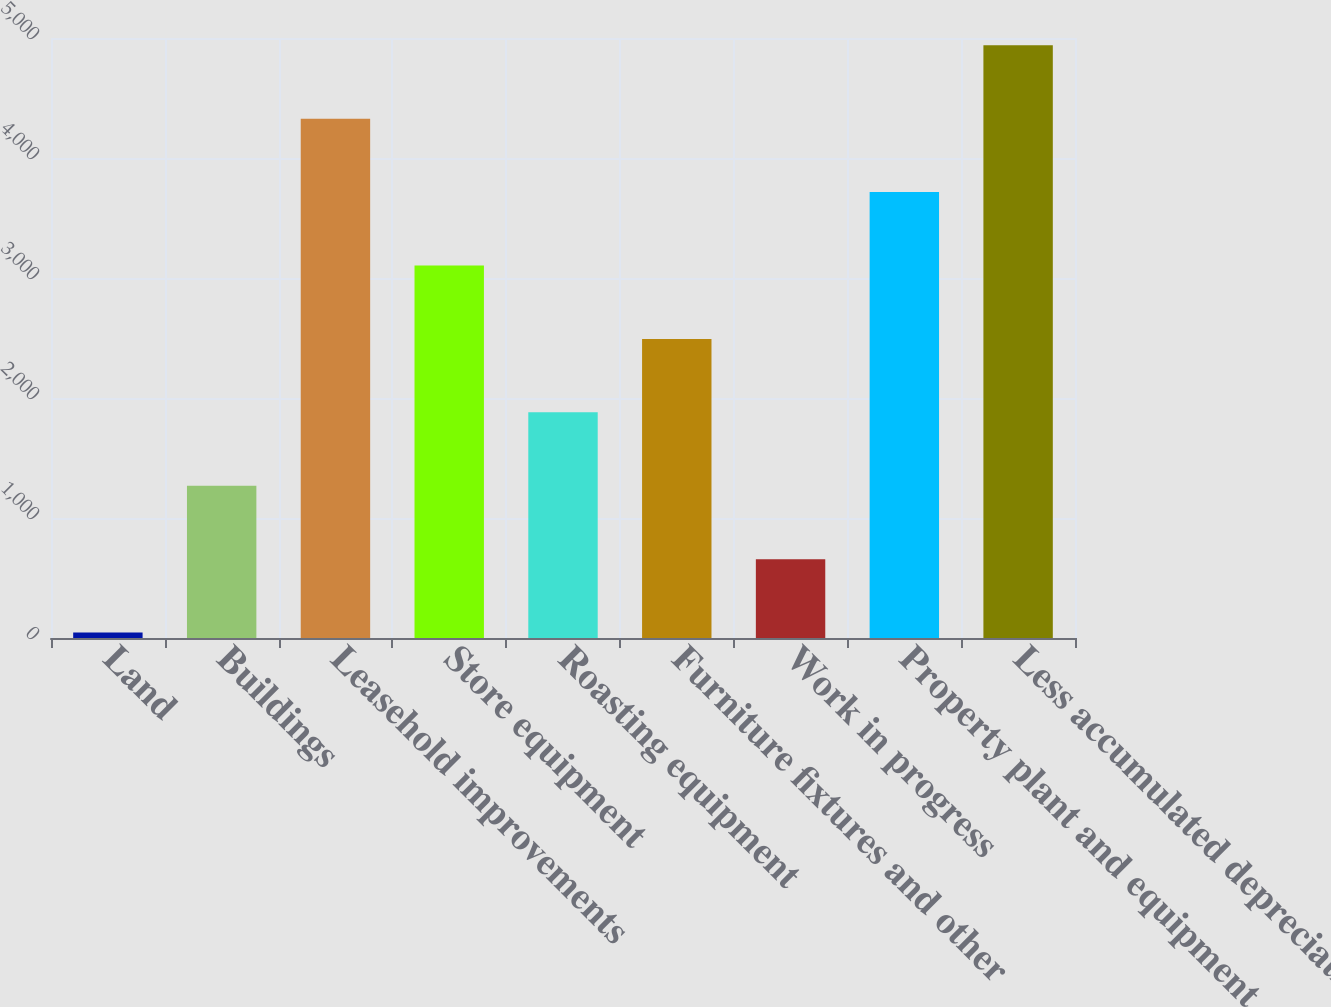Convert chart to OTSL. <chart><loc_0><loc_0><loc_500><loc_500><bar_chart><fcel>Land<fcel>Buildings<fcel>Leasehold improvements<fcel>Store equipment<fcel>Roasting equipment<fcel>Furniture fixtures and other<fcel>Work in progress<fcel>Property plant and equipment<fcel>Less accumulated depreciation<nl><fcel>44.8<fcel>1268.46<fcel>4327.61<fcel>3103.95<fcel>1880.29<fcel>2492.12<fcel>656.63<fcel>3715.78<fcel>4939.44<nl></chart> 